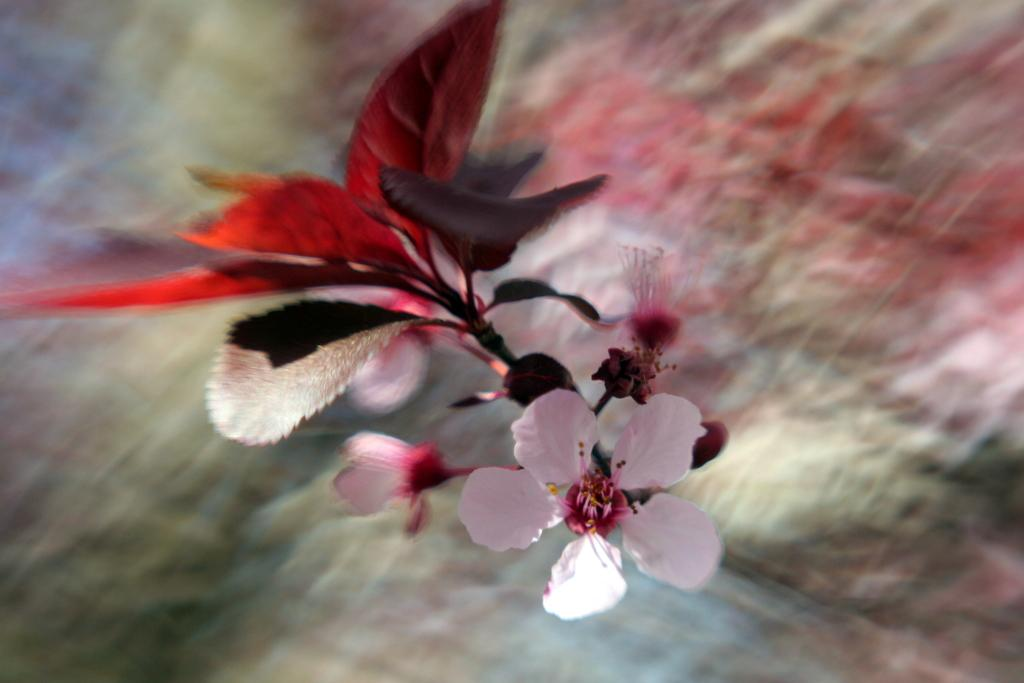What is present in the image? There is a plant in the image. Can you describe the plant in more detail? The plant has a flower. What level of disgust can be observed in the plant's expression in the image? There is no expression present in the image, as plants do not have facial expressions. 